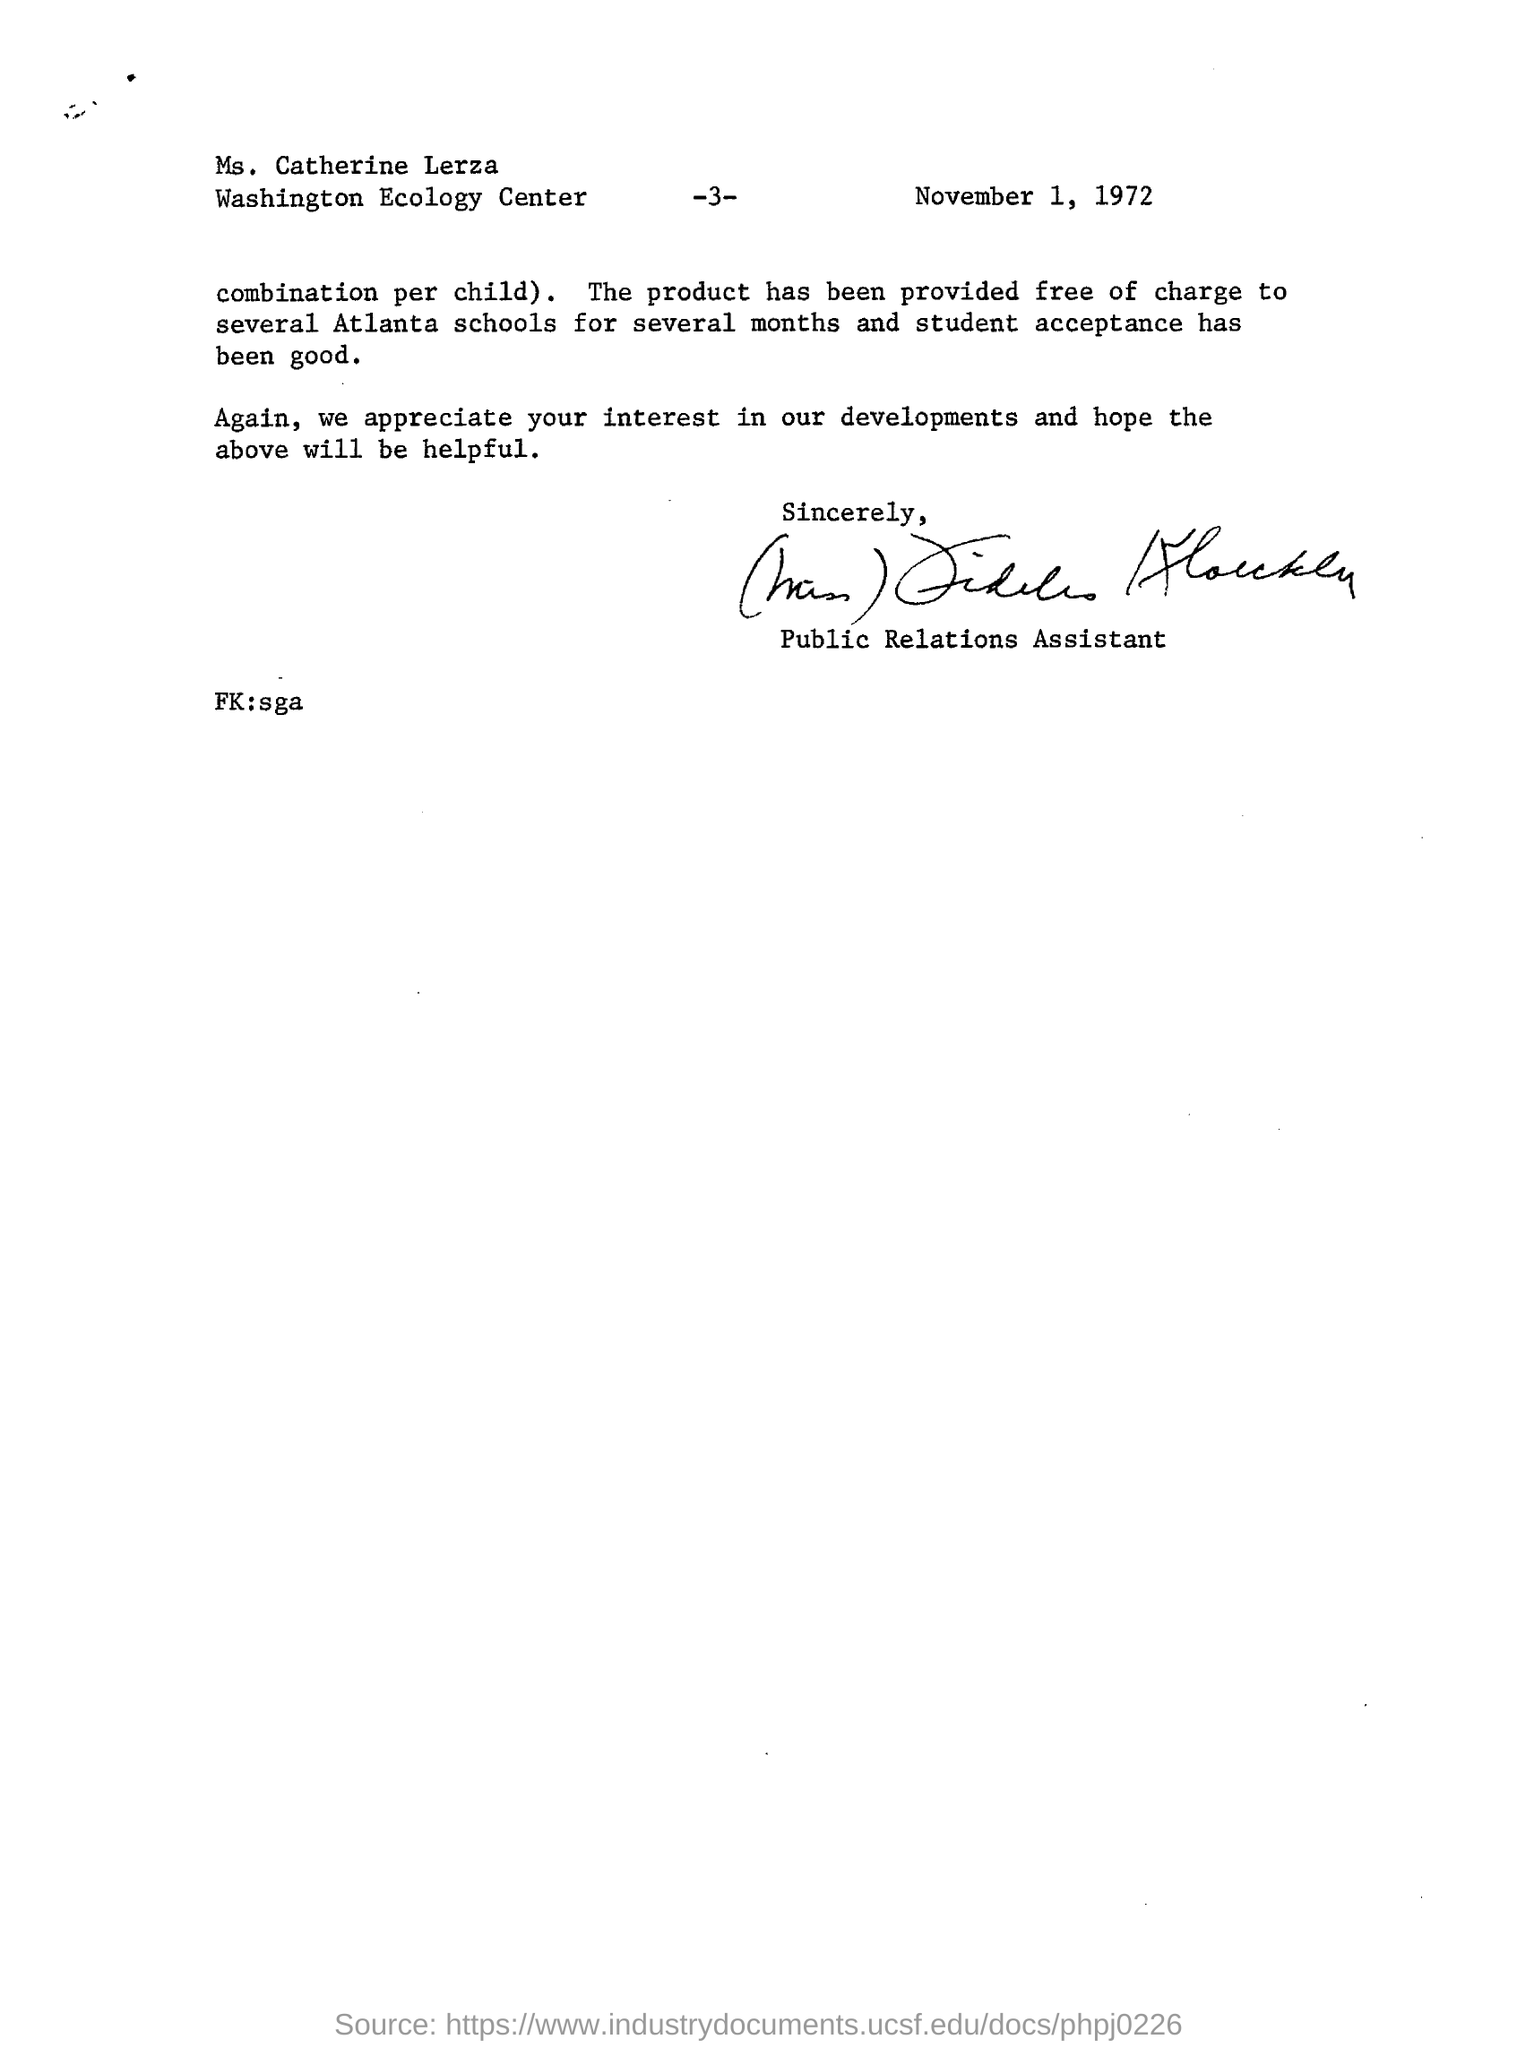Specify some key components in this picture. The letter was dated November 1, 1972. The page number mentioned in this letter is -3-. The sender in this letter is designated as a public relations assistant. 